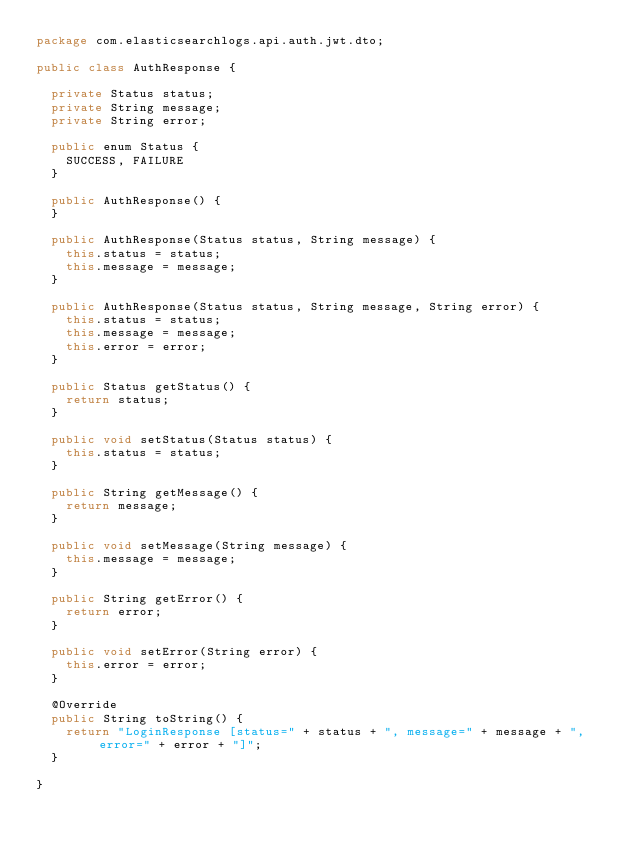Convert code to text. <code><loc_0><loc_0><loc_500><loc_500><_Java_>package com.elasticsearchlogs.api.auth.jwt.dto;

public class AuthResponse {

	private Status status;
	private String message;
	private String error;

	public enum Status {
		SUCCESS, FAILURE
	}

	public AuthResponse() {
	}

	public AuthResponse(Status status, String message) {
		this.status = status;
		this.message = message;
	}

	public AuthResponse(Status status, String message, String error) {
		this.status = status;
		this.message = message;
		this.error = error;
	}

	public Status getStatus() {
		return status;
	}

	public void setStatus(Status status) {
		this.status = status;
	}

	public String getMessage() {
		return message;
	}

	public void setMessage(String message) {
		this.message = message;
	}

	public String getError() {
		return error;
	}

	public void setError(String error) {
		this.error = error;
	}

	@Override
	public String toString() {
		return "LoginResponse [status=" + status + ", message=" + message + ", error=" + error + "]";
	}

}
</code> 